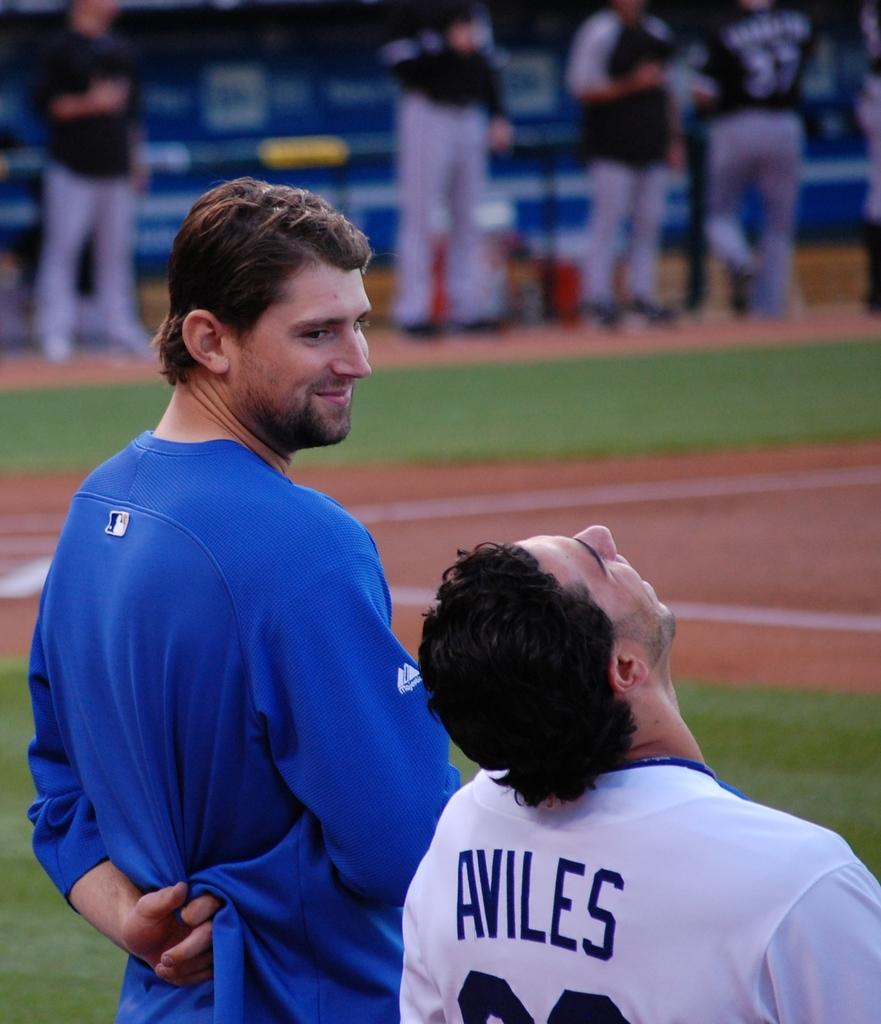Whose name is on the jersey?
Ensure brevity in your answer.  Aviles. 